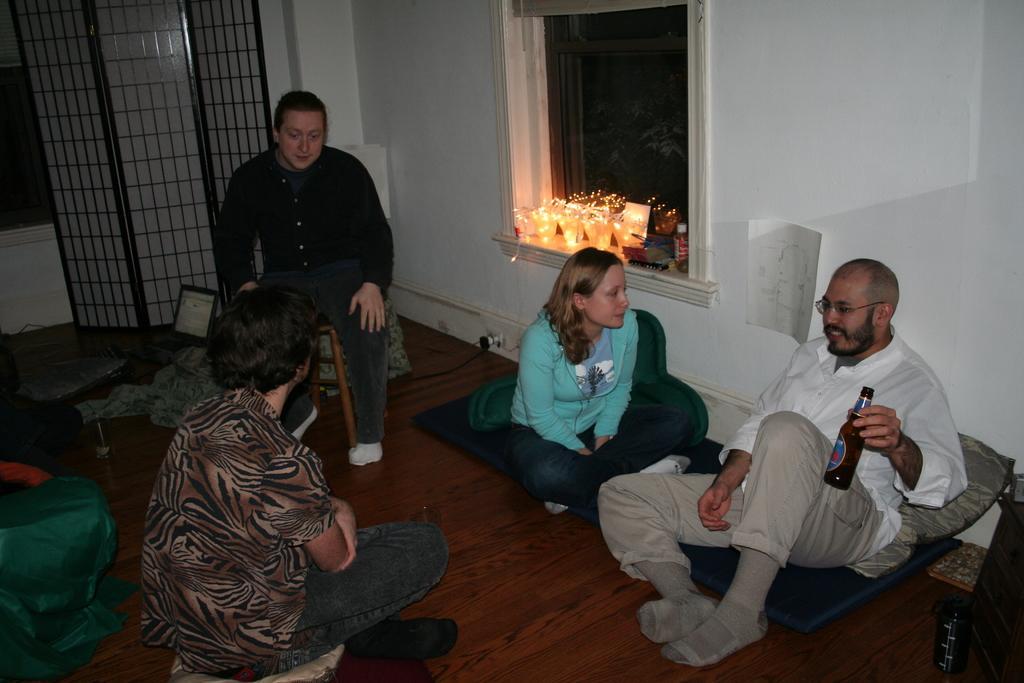How would you summarize this image in a sentence or two? This picture describes about group of people, few are seated on the floor and a man is seated on the chair, on the right side of the image we can see a man, he wore spectacles and he is holding a bottle, behind him we can see lights and a paper on the wall. 